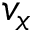<formula> <loc_0><loc_0><loc_500><loc_500>v _ { x }</formula> 